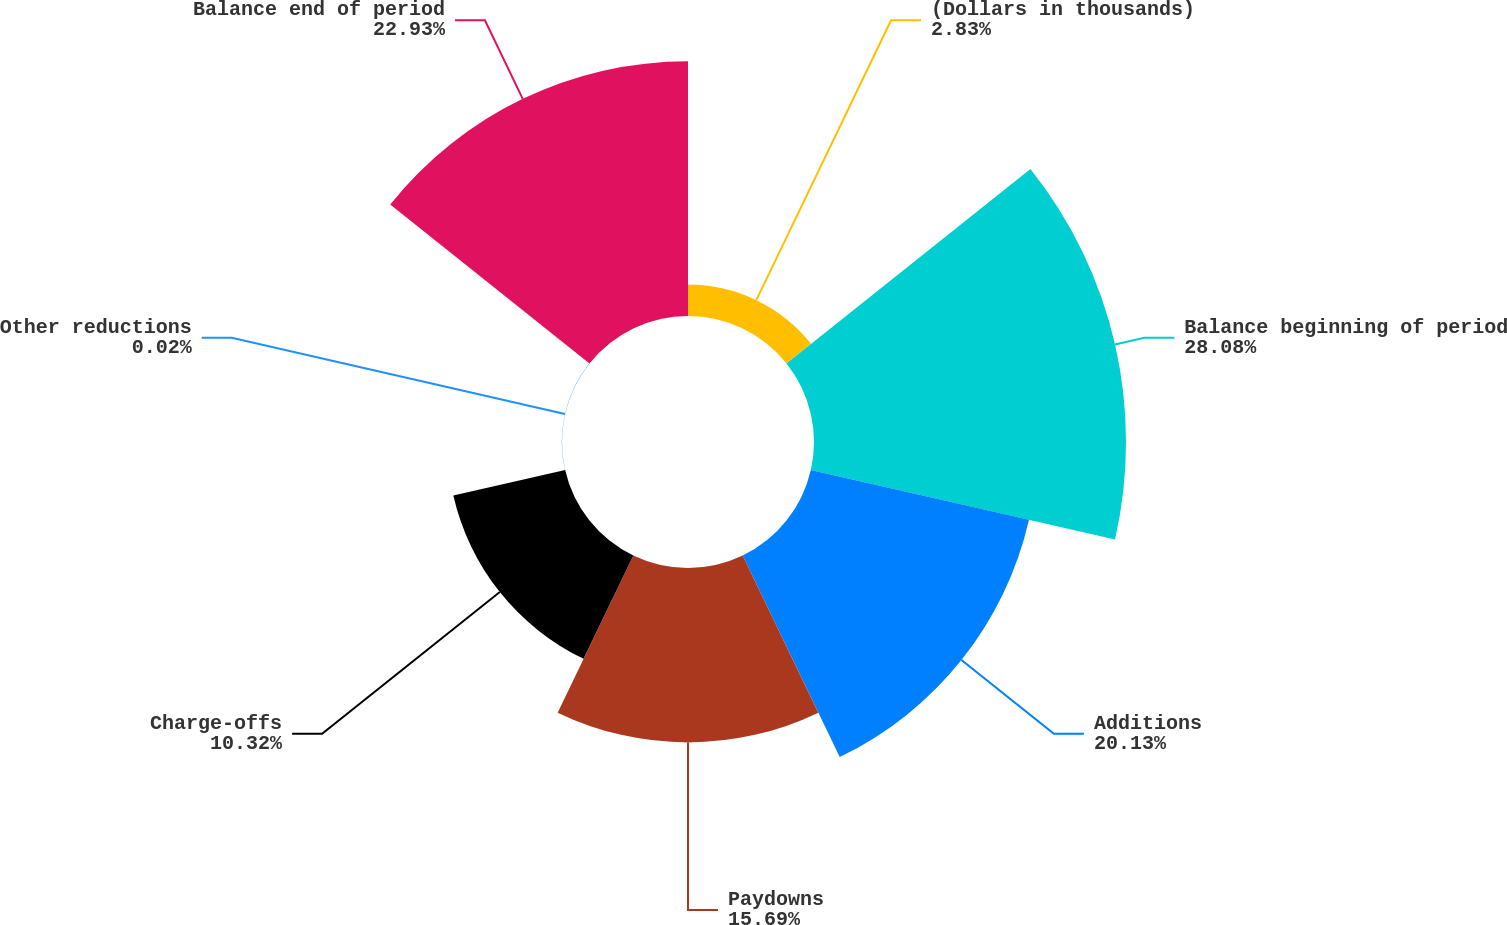Convert chart. <chart><loc_0><loc_0><loc_500><loc_500><pie_chart><fcel>(Dollars in thousands)<fcel>Balance beginning of period<fcel>Additions<fcel>Paydowns<fcel>Charge-offs<fcel>Other reductions<fcel>Balance end of period<nl><fcel>2.83%<fcel>28.07%<fcel>20.13%<fcel>15.69%<fcel>10.32%<fcel>0.02%<fcel>22.93%<nl></chart> 